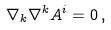Convert formula to latex. <formula><loc_0><loc_0><loc_500><loc_500>\nabla _ { k } \nabla ^ { k } A ^ { i } = 0 \, ,</formula> 